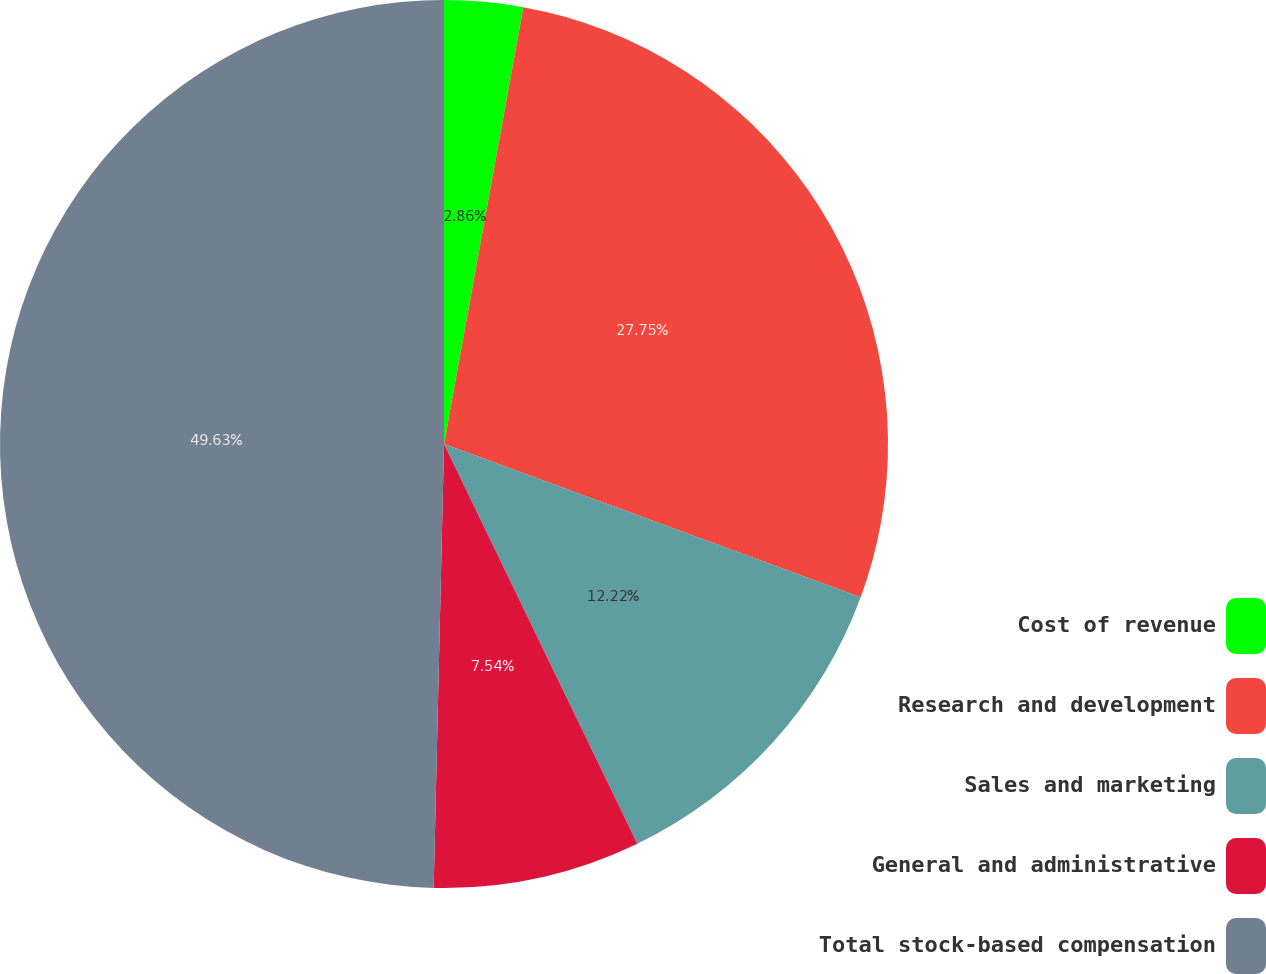Convert chart. <chart><loc_0><loc_0><loc_500><loc_500><pie_chart><fcel>Cost of revenue<fcel>Research and development<fcel>Sales and marketing<fcel>General and administrative<fcel>Total stock-based compensation<nl><fcel>2.86%<fcel>27.75%<fcel>12.22%<fcel>7.54%<fcel>49.63%<nl></chart> 